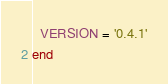Convert code to text. <code><loc_0><loc_0><loc_500><loc_500><_Ruby_>  VERSION = '0.4.1'
end
</code> 